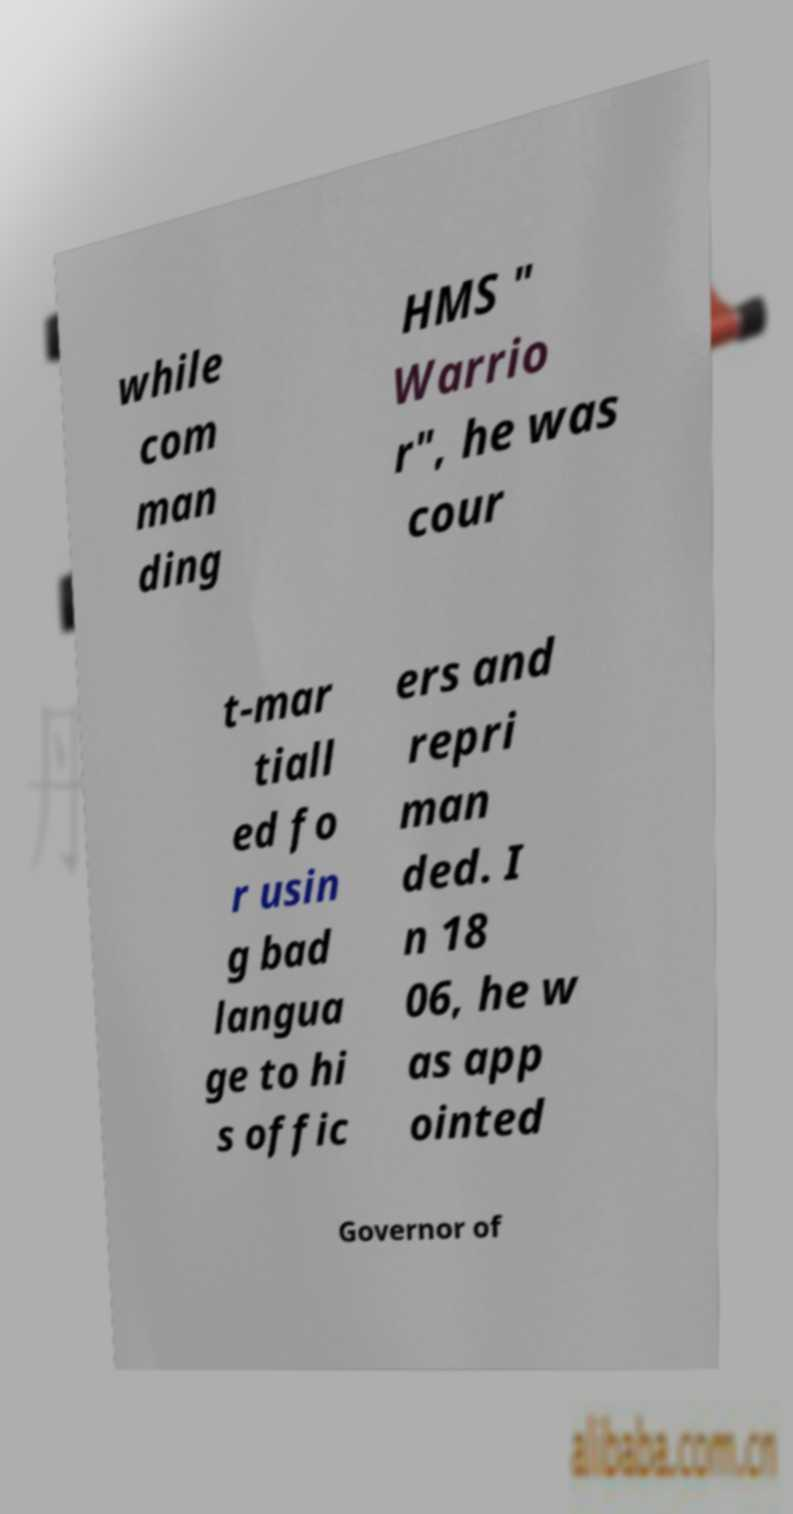Please identify and transcribe the text found in this image. while com man ding HMS " Warrio r", he was cour t-mar tiall ed fo r usin g bad langua ge to hi s offic ers and repri man ded. I n 18 06, he w as app ointed Governor of 